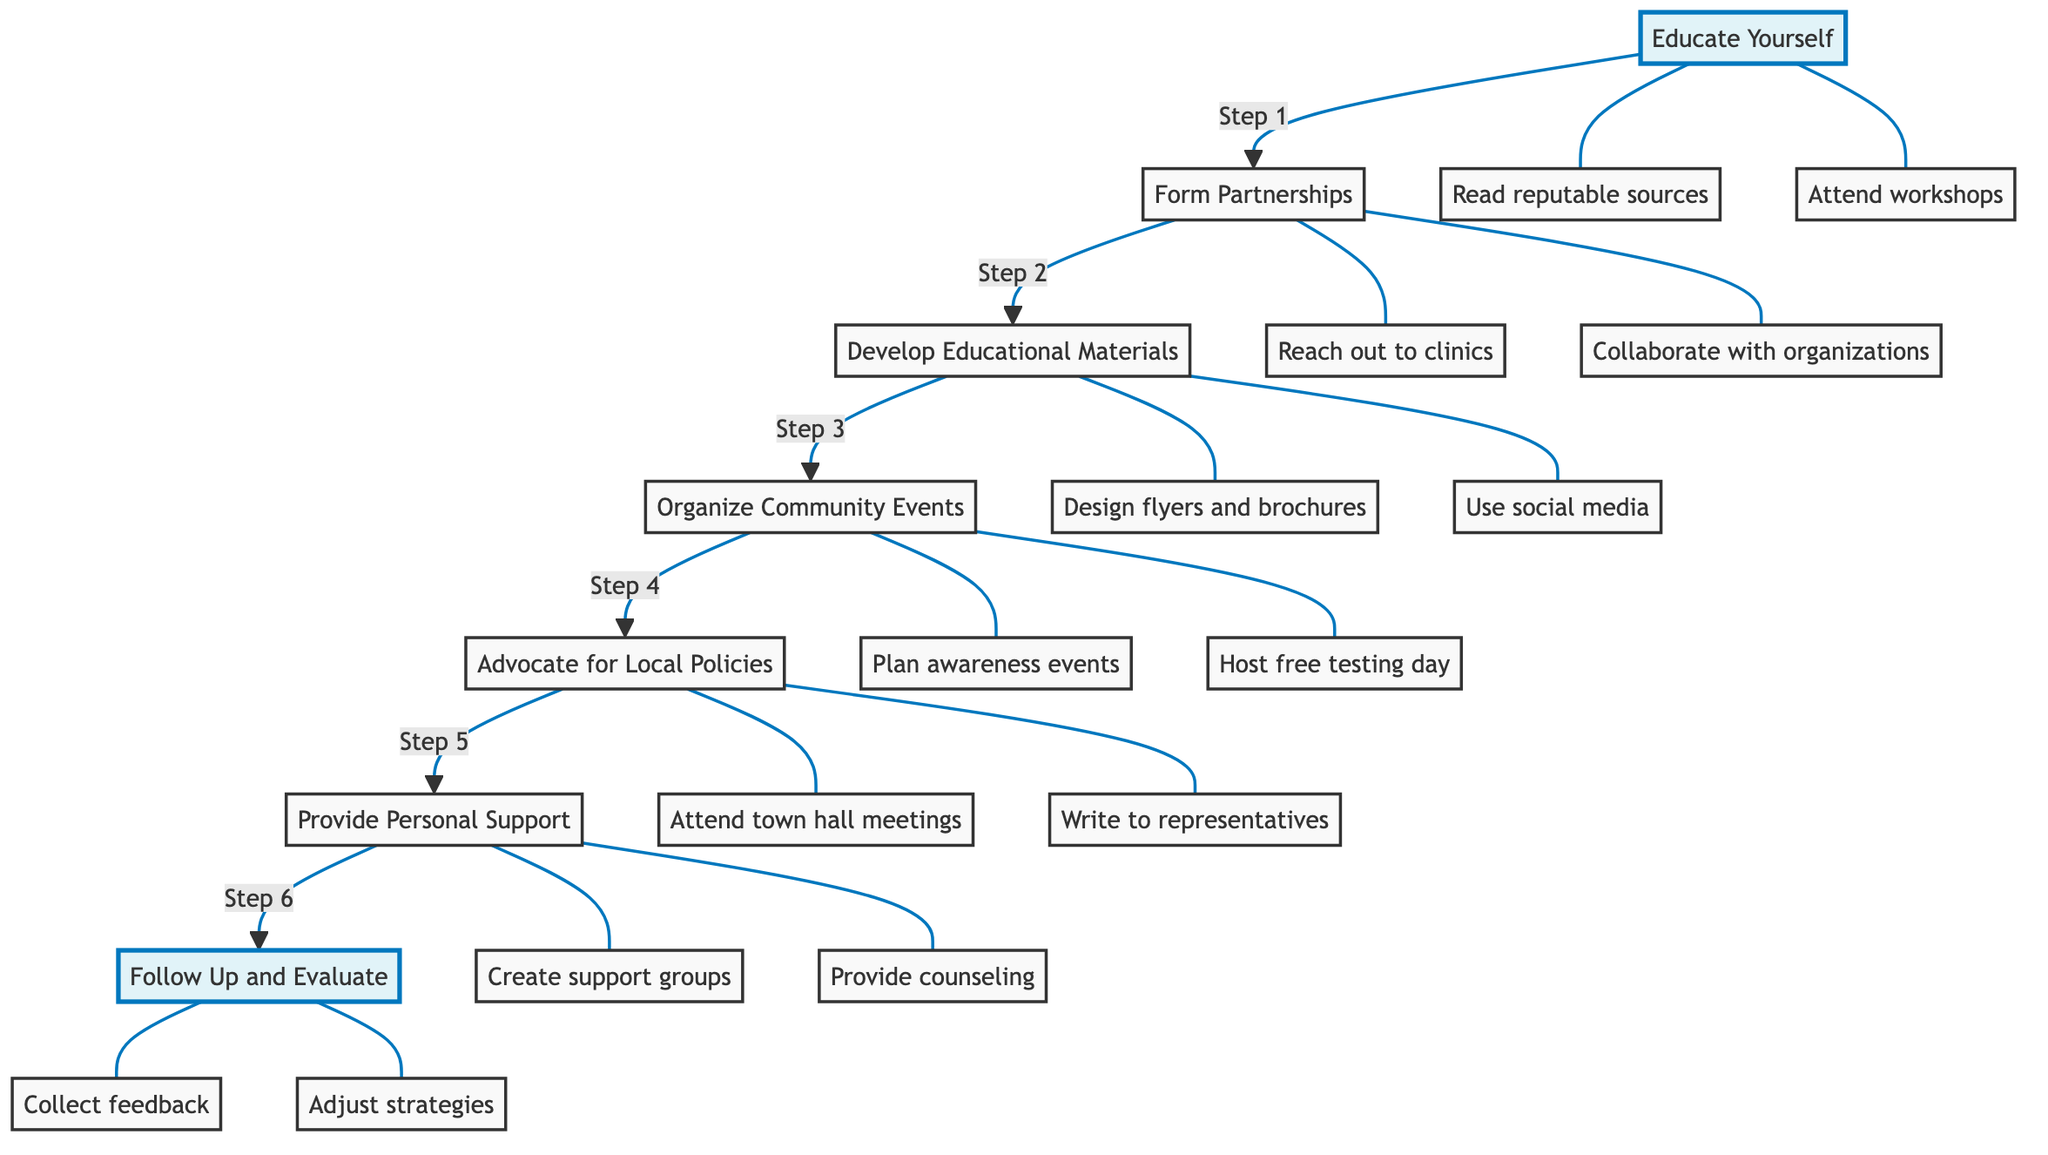What is the first step in advocating for HIV testing? The first step listed in the diagram is "Educate Yourself." This information is found at the top of the flowchart and serves as the starting point for the advocacy process.
Answer: Educate Yourself How many total steps are outlined in the flowchart? The diagram lists a total of seven steps from "Educate Yourself" to "Follow Up and Evaluate." Counting each step shows there are seven in total.
Answer: 7 What action is associated with the "Organize Community Events" step? One of the actions listed under "Organize Community Events" is "Plan an HIV awareness walk or run." It is the first action related to this step in the diagram.
Answer: Plan an HIV awareness walk or run Which step comes after "Form Partnerships"? The diagram shows that after "Form Partnerships," the next step is "Develop Educational Materials." This flow connection indicates the progression of advocacy actions.
Answer: Develop Educational Materials What is the last step in the advocacy process? The final step in the advocacy process as per the diagram is "Follow Up and Evaluate," which is the last node in the flow.
Answer: Follow Up and Evaluate How many actions are listed under the step "Advocate for Local Policies"? Under the step "Advocate for Local Policies," there are two actions listed: "Attend town hall meetings" and "Write to representatives." Counting these gives a total of two actions.
Answer: 2 What is the purpose of the "Provide Personal Support" step? The "Provide Personal Support" step is designed to offer emotional and informational support to individuals considering or undergoing HIV testing. This information can be found in the description associated with this step.
Answer: Offer emotional and informational support What is the action that relates to social media in the educational materials step? The action related to social media under the "Develop Educational Materials" step is "Use social media platforms to share information and resources." This action emphasizes the use of digital platforms for advocacy.
Answer: Use social media platforms to share information and resources 